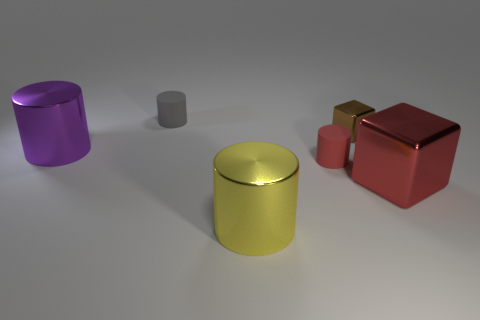Add 2 purple things. How many objects exist? 8 Subtract all blocks. How many objects are left? 4 Add 3 brown things. How many brown things are left? 4 Add 1 matte things. How many matte things exist? 3 Subtract 0 cyan cylinders. How many objects are left? 6 Subtract all tiny objects. Subtract all purple blocks. How many objects are left? 3 